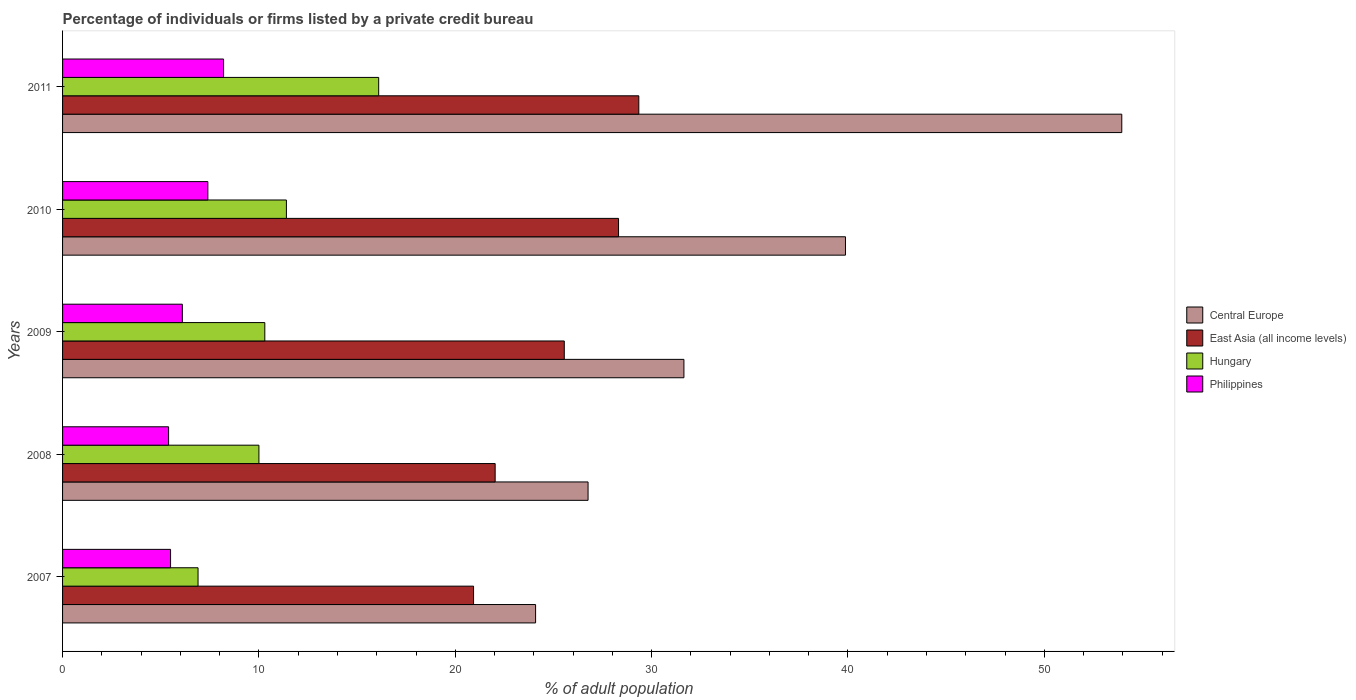How many bars are there on the 5th tick from the top?
Make the answer very short. 4. In how many cases, is the number of bars for a given year not equal to the number of legend labels?
Offer a very short reply. 0. Across all years, what is the maximum percentage of population listed by a private credit bureau in Central Europe?
Provide a short and direct response. 53.95. In which year was the percentage of population listed by a private credit bureau in East Asia (all income levels) maximum?
Your response must be concise. 2011. What is the total percentage of population listed by a private credit bureau in Central Europe in the graph?
Keep it short and to the point. 176.32. What is the difference between the percentage of population listed by a private credit bureau in Philippines in 2009 and that in 2011?
Keep it short and to the point. -2.1. What is the difference between the percentage of population listed by a private credit bureau in Philippines in 2011 and the percentage of population listed by a private credit bureau in Hungary in 2007?
Make the answer very short. 1.3. What is the average percentage of population listed by a private credit bureau in Hungary per year?
Your response must be concise. 10.94. In the year 2008, what is the difference between the percentage of population listed by a private credit bureau in East Asia (all income levels) and percentage of population listed by a private credit bureau in Hungary?
Offer a terse response. 12.03. What is the ratio of the percentage of population listed by a private credit bureau in Philippines in 2007 to that in 2008?
Ensure brevity in your answer.  1.02. Is the percentage of population listed by a private credit bureau in Central Europe in 2008 less than that in 2010?
Provide a succinct answer. Yes. What is the difference between the highest and the second highest percentage of population listed by a private credit bureau in Philippines?
Provide a short and direct response. 0.8. What is the difference between the highest and the lowest percentage of population listed by a private credit bureau in Philippines?
Your response must be concise. 2.8. Is the sum of the percentage of population listed by a private credit bureau in Hungary in 2009 and 2010 greater than the maximum percentage of population listed by a private credit bureau in Philippines across all years?
Offer a terse response. Yes. Is it the case that in every year, the sum of the percentage of population listed by a private credit bureau in Philippines and percentage of population listed by a private credit bureau in Central Europe is greater than the sum of percentage of population listed by a private credit bureau in East Asia (all income levels) and percentage of population listed by a private credit bureau in Hungary?
Provide a succinct answer. Yes. What does the 4th bar from the top in 2009 represents?
Ensure brevity in your answer.  Central Europe. What does the 2nd bar from the bottom in 2007 represents?
Keep it short and to the point. East Asia (all income levels). Is it the case that in every year, the sum of the percentage of population listed by a private credit bureau in Central Europe and percentage of population listed by a private credit bureau in East Asia (all income levels) is greater than the percentage of population listed by a private credit bureau in Philippines?
Give a very brief answer. Yes. What is the difference between two consecutive major ticks on the X-axis?
Offer a terse response. 10. Are the values on the major ticks of X-axis written in scientific E-notation?
Your answer should be compact. No. Does the graph contain any zero values?
Keep it short and to the point. No. Does the graph contain grids?
Your answer should be compact. No. Where does the legend appear in the graph?
Your answer should be compact. Center right. How many legend labels are there?
Make the answer very short. 4. How are the legend labels stacked?
Provide a short and direct response. Vertical. What is the title of the graph?
Offer a very short reply. Percentage of individuals or firms listed by a private credit bureau. What is the label or title of the X-axis?
Make the answer very short. % of adult population. What is the label or title of the Y-axis?
Your response must be concise. Years. What is the % of adult population in Central Europe in 2007?
Offer a very short reply. 24.09. What is the % of adult population of East Asia (all income levels) in 2007?
Your answer should be very brief. 20.93. What is the % of adult population of Philippines in 2007?
Offer a very short reply. 5.5. What is the % of adult population of Central Europe in 2008?
Your answer should be very brief. 26.76. What is the % of adult population in East Asia (all income levels) in 2008?
Your response must be concise. 22.03. What is the % of adult population of Central Europe in 2009?
Provide a short and direct response. 31.65. What is the % of adult population in East Asia (all income levels) in 2009?
Provide a succinct answer. 25.55. What is the % of adult population in Central Europe in 2010?
Your answer should be very brief. 39.87. What is the % of adult population of East Asia (all income levels) in 2010?
Your response must be concise. 28.32. What is the % of adult population in Hungary in 2010?
Give a very brief answer. 11.4. What is the % of adult population in Philippines in 2010?
Your answer should be compact. 7.4. What is the % of adult population in Central Europe in 2011?
Your answer should be compact. 53.95. What is the % of adult population in East Asia (all income levels) in 2011?
Provide a short and direct response. 29.35. What is the % of adult population in Hungary in 2011?
Make the answer very short. 16.1. Across all years, what is the maximum % of adult population in Central Europe?
Provide a succinct answer. 53.95. Across all years, what is the maximum % of adult population of East Asia (all income levels)?
Keep it short and to the point. 29.35. Across all years, what is the maximum % of adult population of Philippines?
Offer a terse response. 8.2. Across all years, what is the minimum % of adult population in Central Europe?
Your answer should be very brief. 24.09. Across all years, what is the minimum % of adult population in East Asia (all income levels)?
Offer a very short reply. 20.93. What is the total % of adult population of Central Europe in the graph?
Your answer should be very brief. 176.32. What is the total % of adult population in East Asia (all income levels) in the graph?
Keep it short and to the point. 126.18. What is the total % of adult population of Hungary in the graph?
Offer a terse response. 54.7. What is the total % of adult population of Philippines in the graph?
Provide a short and direct response. 32.6. What is the difference between the % of adult population of Central Europe in 2007 and that in 2008?
Your answer should be very brief. -2.67. What is the difference between the % of adult population of Hungary in 2007 and that in 2008?
Keep it short and to the point. -3.1. What is the difference between the % of adult population of Philippines in 2007 and that in 2008?
Give a very brief answer. 0.1. What is the difference between the % of adult population in Central Europe in 2007 and that in 2009?
Ensure brevity in your answer.  -7.55. What is the difference between the % of adult population in East Asia (all income levels) in 2007 and that in 2009?
Give a very brief answer. -4.62. What is the difference between the % of adult population of Hungary in 2007 and that in 2009?
Make the answer very short. -3.4. What is the difference between the % of adult population in Central Europe in 2007 and that in 2010?
Offer a very short reply. -15.78. What is the difference between the % of adult population of East Asia (all income levels) in 2007 and that in 2010?
Offer a terse response. -7.38. What is the difference between the % of adult population of Philippines in 2007 and that in 2010?
Your response must be concise. -1.9. What is the difference between the % of adult population in Central Europe in 2007 and that in 2011?
Give a very brief answer. -29.85. What is the difference between the % of adult population of East Asia (all income levels) in 2007 and that in 2011?
Your answer should be very brief. -8.42. What is the difference between the % of adult population of Hungary in 2007 and that in 2011?
Your answer should be very brief. -9.2. What is the difference between the % of adult population in Philippines in 2007 and that in 2011?
Your answer should be compact. -2.7. What is the difference between the % of adult population in Central Europe in 2008 and that in 2009?
Give a very brief answer. -4.88. What is the difference between the % of adult population of East Asia (all income levels) in 2008 and that in 2009?
Give a very brief answer. -3.52. What is the difference between the % of adult population in Philippines in 2008 and that in 2009?
Ensure brevity in your answer.  -0.7. What is the difference between the % of adult population of Central Europe in 2008 and that in 2010?
Provide a short and direct response. -13.11. What is the difference between the % of adult population of East Asia (all income levels) in 2008 and that in 2010?
Keep it short and to the point. -6.28. What is the difference between the % of adult population in Hungary in 2008 and that in 2010?
Offer a very short reply. -1.4. What is the difference between the % of adult population of Central Europe in 2008 and that in 2011?
Give a very brief answer. -27.18. What is the difference between the % of adult population in East Asia (all income levels) in 2008 and that in 2011?
Keep it short and to the point. -7.32. What is the difference between the % of adult population of Philippines in 2008 and that in 2011?
Give a very brief answer. -2.8. What is the difference between the % of adult population of Central Europe in 2009 and that in 2010?
Provide a short and direct response. -8.23. What is the difference between the % of adult population of East Asia (all income levels) in 2009 and that in 2010?
Your answer should be very brief. -2.76. What is the difference between the % of adult population of Philippines in 2009 and that in 2010?
Keep it short and to the point. -1.3. What is the difference between the % of adult population in Central Europe in 2009 and that in 2011?
Offer a terse response. -22.3. What is the difference between the % of adult population of East Asia (all income levels) in 2009 and that in 2011?
Give a very brief answer. -3.8. What is the difference between the % of adult population of Hungary in 2009 and that in 2011?
Give a very brief answer. -5.8. What is the difference between the % of adult population in Philippines in 2009 and that in 2011?
Your answer should be compact. -2.1. What is the difference between the % of adult population of Central Europe in 2010 and that in 2011?
Your response must be concise. -14.07. What is the difference between the % of adult population of East Asia (all income levels) in 2010 and that in 2011?
Your answer should be very brief. -1.03. What is the difference between the % of adult population in Philippines in 2010 and that in 2011?
Keep it short and to the point. -0.8. What is the difference between the % of adult population in Central Europe in 2007 and the % of adult population in East Asia (all income levels) in 2008?
Make the answer very short. 2.06. What is the difference between the % of adult population of Central Europe in 2007 and the % of adult population of Hungary in 2008?
Give a very brief answer. 14.09. What is the difference between the % of adult population in Central Europe in 2007 and the % of adult population in Philippines in 2008?
Keep it short and to the point. 18.69. What is the difference between the % of adult population in East Asia (all income levels) in 2007 and the % of adult population in Hungary in 2008?
Your answer should be very brief. 10.93. What is the difference between the % of adult population in East Asia (all income levels) in 2007 and the % of adult population in Philippines in 2008?
Keep it short and to the point. 15.53. What is the difference between the % of adult population of Hungary in 2007 and the % of adult population of Philippines in 2008?
Provide a short and direct response. 1.5. What is the difference between the % of adult population of Central Europe in 2007 and the % of adult population of East Asia (all income levels) in 2009?
Your answer should be very brief. -1.46. What is the difference between the % of adult population of Central Europe in 2007 and the % of adult population of Hungary in 2009?
Provide a short and direct response. 13.79. What is the difference between the % of adult population of Central Europe in 2007 and the % of adult population of Philippines in 2009?
Your response must be concise. 17.99. What is the difference between the % of adult population of East Asia (all income levels) in 2007 and the % of adult population of Hungary in 2009?
Provide a succinct answer. 10.63. What is the difference between the % of adult population in East Asia (all income levels) in 2007 and the % of adult population in Philippines in 2009?
Offer a terse response. 14.83. What is the difference between the % of adult population in Hungary in 2007 and the % of adult population in Philippines in 2009?
Your response must be concise. 0.8. What is the difference between the % of adult population of Central Europe in 2007 and the % of adult population of East Asia (all income levels) in 2010?
Keep it short and to the point. -4.23. What is the difference between the % of adult population of Central Europe in 2007 and the % of adult population of Hungary in 2010?
Offer a terse response. 12.69. What is the difference between the % of adult population in Central Europe in 2007 and the % of adult population in Philippines in 2010?
Keep it short and to the point. 16.69. What is the difference between the % of adult population in East Asia (all income levels) in 2007 and the % of adult population in Hungary in 2010?
Provide a succinct answer. 9.53. What is the difference between the % of adult population of East Asia (all income levels) in 2007 and the % of adult population of Philippines in 2010?
Make the answer very short. 13.53. What is the difference between the % of adult population of Central Europe in 2007 and the % of adult population of East Asia (all income levels) in 2011?
Your answer should be very brief. -5.26. What is the difference between the % of adult population of Central Europe in 2007 and the % of adult population of Hungary in 2011?
Provide a succinct answer. 7.99. What is the difference between the % of adult population of Central Europe in 2007 and the % of adult population of Philippines in 2011?
Your answer should be very brief. 15.89. What is the difference between the % of adult population of East Asia (all income levels) in 2007 and the % of adult population of Hungary in 2011?
Your answer should be very brief. 4.83. What is the difference between the % of adult population of East Asia (all income levels) in 2007 and the % of adult population of Philippines in 2011?
Provide a succinct answer. 12.73. What is the difference between the % of adult population in Hungary in 2007 and the % of adult population in Philippines in 2011?
Ensure brevity in your answer.  -1.3. What is the difference between the % of adult population of Central Europe in 2008 and the % of adult population of East Asia (all income levels) in 2009?
Give a very brief answer. 1.21. What is the difference between the % of adult population in Central Europe in 2008 and the % of adult population in Hungary in 2009?
Make the answer very short. 16.46. What is the difference between the % of adult population of Central Europe in 2008 and the % of adult population of Philippines in 2009?
Offer a very short reply. 20.66. What is the difference between the % of adult population of East Asia (all income levels) in 2008 and the % of adult population of Hungary in 2009?
Offer a terse response. 11.73. What is the difference between the % of adult population in East Asia (all income levels) in 2008 and the % of adult population in Philippines in 2009?
Your answer should be compact. 15.93. What is the difference between the % of adult population of Central Europe in 2008 and the % of adult population of East Asia (all income levels) in 2010?
Provide a short and direct response. -1.55. What is the difference between the % of adult population of Central Europe in 2008 and the % of adult population of Hungary in 2010?
Offer a terse response. 15.36. What is the difference between the % of adult population of Central Europe in 2008 and the % of adult population of Philippines in 2010?
Your answer should be compact. 19.36. What is the difference between the % of adult population in East Asia (all income levels) in 2008 and the % of adult population in Hungary in 2010?
Provide a succinct answer. 10.63. What is the difference between the % of adult population of East Asia (all income levels) in 2008 and the % of adult population of Philippines in 2010?
Ensure brevity in your answer.  14.63. What is the difference between the % of adult population in Central Europe in 2008 and the % of adult population in East Asia (all income levels) in 2011?
Your answer should be compact. -2.58. What is the difference between the % of adult population in Central Europe in 2008 and the % of adult population in Hungary in 2011?
Provide a succinct answer. 10.66. What is the difference between the % of adult population of Central Europe in 2008 and the % of adult population of Philippines in 2011?
Ensure brevity in your answer.  18.56. What is the difference between the % of adult population of East Asia (all income levels) in 2008 and the % of adult population of Hungary in 2011?
Offer a terse response. 5.93. What is the difference between the % of adult population in East Asia (all income levels) in 2008 and the % of adult population in Philippines in 2011?
Make the answer very short. 13.83. What is the difference between the % of adult population of Central Europe in 2009 and the % of adult population of East Asia (all income levels) in 2010?
Make the answer very short. 3.33. What is the difference between the % of adult population of Central Europe in 2009 and the % of adult population of Hungary in 2010?
Offer a very short reply. 20.25. What is the difference between the % of adult population in Central Europe in 2009 and the % of adult population in Philippines in 2010?
Offer a terse response. 24.25. What is the difference between the % of adult population in East Asia (all income levels) in 2009 and the % of adult population in Hungary in 2010?
Your response must be concise. 14.15. What is the difference between the % of adult population of East Asia (all income levels) in 2009 and the % of adult population of Philippines in 2010?
Offer a very short reply. 18.15. What is the difference between the % of adult population of Central Europe in 2009 and the % of adult population of East Asia (all income levels) in 2011?
Provide a succinct answer. 2.3. What is the difference between the % of adult population of Central Europe in 2009 and the % of adult population of Hungary in 2011?
Keep it short and to the point. 15.55. What is the difference between the % of adult population of Central Europe in 2009 and the % of adult population of Philippines in 2011?
Make the answer very short. 23.45. What is the difference between the % of adult population of East Asia (all income levels) in 2009 and the % of adult population of Hungary in 2011?
Give a very brief answer. 9.45. What is the difference between the % of adult population of East Asia (all income levels) in 2009 and the % of adult population of Philippines in 2011?
Offer a very short reply. 17.35. What is the difference between the % of adult population in Hungary in 2009 and the % of adult population in Philippines in 2011?
Your response must be concise. 2.1. What is the difference between the % of adult population of Central Europe in 2010 and the % of adult population of East Asia (all income levels) in 2011?
Your response must be concise. 10.52. What is the difference between the % of adult population of Central Europe in 2010 and the % of adult population of Hungary in 2011?
Your response must be concise. 23.77. What is the difference between the % of adult population of Central Europe in 2010 and the % of adult population of Philippines in 2011?
Make the answer very short. 31.67. What is the difference between the % of adult population in East Asia (all income levels) in 2010 and the % of adult population in Hungary in 2011?
Your answer should be compact. 12.22. What is the difference between the % of adult population in East Asia (all income levels) in 2010 and the % of adult population in Philippines in 2011?
Offer a terse response. 20.12. What is the average % of adult population of Central Europe per year?
Make the answer very short. 35.26. What is the average % of adult population of East Asia (all income levels) per year?
Provide a short and direct response. 25.24. What is the average % of adult population in Hungary per year?
Provide a succinct answer. 10.94. What is the average % of adult population of Philippines per year?
Ensure brevity in your answer.  6.52. In the year 2007, what is the difference between the % of adult population of Central Europe and % of adult population of East Asia (all income levels)?
Offer a very short reply. 3.16. In the year 2007, what is the difference between the % of adult population in Central Europe and % of adult population in Hungary?
Provide a short and direct response. 17.19. In the year 2007, what is the difference between the % of adult population of Central Europe and % of adult population of Philippines?
Provide a succinct answer. 18.59. In the year 2007, what is the difference between the % of adult population of East Asia (all income levels) and % of adult population of Hungary?
Offer a terse response. 14.03. In the year 2007, what is the difference between the % of adult population of East Asia (all income levels) and % of adult population of Philippines?
Keep it short and to the point. 15.43. In the year 2008, what is the difference between the % of adult population of Central Europe and % of adult population of East Asia (all income levels)?
Provide a short and direct response. 4.73. In the year 2008, what is the difference between the % of adult population in Central Europe and % of adult population in Hungary?
Ensure brevity in your answer.  16.76. In the year 2008, what is the difference between the % of adult population in Central Europe and % of adult population in Philippines?
Ensure brevity in your answer.  21.36. In the year 2008, what is the difference between the % of adult population of East Asia (all income levels) and % of adult population of Hungary?
Keep it short and to the point. 12.03. In the year 2008, what is the difference between the % of adult population of East Asia (all income levels) and % of adult population of Philippines?
Provide a short and direct response. 16.63. In the year 2008, what is the difference between the % of adult population of Hungary and % of adult population of Philippines?
Your answer should be compact. 4.6. In the year 2009, what is the difference between the % of adult population in Central Europe and % of adult population in East Asia (all income levels)?
Your answer should be very brief. 6.09. In the year 2009, what is the difference between the % of adult population of Central Europe and % of adult population of Hungary?
Offer a terse response. 21.35. In the year 2009, what is the difference between the % of adult population of Central Europe and % of adult population of Philippines?
Ensure brevity in your answer.  25.55. In the year 2009, what is the difference between the % of adult population of East Asia (all income levels) and % of adult population of Hungary?
Your answer should be very brief. 15.25. In the year 2009, what is the difference between the % of adult population in East Asia (all income levels) and % of adult population in Philippines?
Offer a very short reply. 19.45. In the year 2010, what is the difference between the % of adult population of Central Europe and % of adult population of East Asia (all income levels)?
Your response must be concise. 11.56. In the year 2010, what is the difference between the % of adult population of Central Europe and % of adult population of Hungary?
Give a very brief answer. 28.47. In the year 2010, what is the difference between the % of adult population in Central Europe and % of adult population in Philippines?
Offer a terse response. 32.47. In the year 2010, what is the difference between the % of adult population in East Asia (all income levels) and % of adult population in Hungary?
Your answer should be very brief. 16.92. In the year 2010, what is the difference between the % of adult population in East Asia (all income levels) and % of adult population in Philippines?
Offer a terse response. 20.92. In the year 2011, what is the difference between the % of adult population in Central Europe and % of adult population in East Asia (all income levels)?
Offer a very short reply. 24.6. In the year 2011, what is the difference between the % of adult population in Central Europe and % of adult population in Hungary?
Your answer should be compact. 37.85. In the year 2011, what is the difference between the % of adult population in Central Europe and % of adult population in Philippines?
Your answer should be compact. 45.75. In the year 2011, what is the difference between the % of adult population of East Asia (all income levels) and % of adult population of Hungary?
Your answer should be very brief. 13.25. In the year 2011, what is the difference between the % of adult population in East Asia (all income levels) and % of adult population in Philippines?
Give a very brief answer. 21.15. In the year 2011, what is the difference between the % of adult population in Hungary and % of adult population in Philippines?
Keep it short and to the point. 7.9. What is the ratio of the % of adult population of Central Europe in 2007 to that in 2008?
Your answer should be very brief. 0.9. What is the ratio of the % of adult population in East Asia (all income levels) in 2007 to that in 2008?
Keep it short and to the point. 0.95. What is the ratio of the % of adult population of Hungary in 2007 to that in 2008?
Provide a succinct answer. 0.69. What is the ratio of the % of adult population in Philippines in 2007 to that in 2008?
Ensure brevity in your answer.  1.02. What is the ratio of the % of adult population of Central Europe in 2007 to that in 2009?
Your response must be concise. 0.76. What is the ratio of the % of adult population in East Asia (all income levels) in 2007 to that in 2009?
Offer a very short reply. 0.82. What is the ratio of the % of adult population of Hungary in 2007 to that in 2009?
Offer a very short reply. 0.67. What is the ratio of the % of adult population of Philippines in 2007 to that in 2009?
Your answer should be very brief. 0.9. What is the ratio of the % of adult population in Central Europe in 2007 to that in 2010?
Your answer should be very brief. 0.6. What is the ratio of the % of adult population in East Asia (all income levels) in 2007 to that in 2010?
Your answer should be very brief. 0.74. What is the ratio of the % of adult population of Hungary in 2007 to that in 2010?
Provide a short and direct response. 0.61. What is the ratio of the % of adult population of Philippines in 2007 to that in 2010?
Ensure brevity in your answer.  0.74. What is the ratio of the % of adult population in Central Europe in 2007 to that in 2011?
Keep it short and to the point. 0.45. What is the ratio of the % of adult population in East Asia (all income levels) in 2007 to that in 2011?
Offer a very short reply. 0.71. What is the ratio of the % of adult population in Hungary in 2007 to that in 2011?
Your response must be concise. 0.43. What is the ratio of the % of adult population in Philippines in 2007 to that in 2011?
Provide a succinct answer. 0.67. What is the ratio of the % of adult population of Central Europe in 2008 to that in 2009?
Provide a short and direct response. 0.85. What is the ratio of the % of adult population in East Asia (all income levels) in 2008 to that in 2009?
Ensure brevity in your answer.  0.86. What is the ratio of the % of adult population of Hungary in 2008 to that in 2009?
Offer a terse response. 0.97. What is the ratio of the % of adult population in Philippines in 2008 to that in 2009?
Your answer should be very brief. 0.89. What is the ratio of the % of adult population of Central Europe in 2008 to that in 2010?
Ensure brevity in your answer.  0.67. What is the ratio of the % of adult population of East Asia (all income levels) in 2008 to that in 2010?
Your answer should be compact. 0.78. What is the ratio of the % of adult population of Hungary in 2008 to that in 2010?
Your answer should be compact. 0.88. What is the ratio of the % of adult population in Philippines in 2008 to that in 2010?
Provide a short and direct response. 0.73. What is the ratio of the % of adult population of Central Europe in 2008 to that in 2011?
Offer a terse response. 0.5. What is the ratio of the % of adult population of East Asia (all income levels) in 2008 to that in 2011?
Keep it short and to the point. 0.75. What is the ratio of the % of adult population in Hungary in 2008 to that in 2011?
Keep it short and to the point. 0.62. What is the ratio of the % of adult population in Philippines in 2008 to that in 2011?
Give a very brief answer. 0.66. What is the ratio of the % of adult population of Central Europe in 2009 to that in 2010?
Give a very brief answer. 0.79. What is the ratio of the % of adult population in East Asia (all income levels) in 2009 to that in 2010?
Provide a short and direct response. 0.9. What is the ratio of the % of adult population of Hungary in 2009 to that in 2010?
Your answer should be very brief. 0.9. What is the ratio of the % of adult population of Philippines in 2009 to that in 2010?
Provide a succinct answer. 0.82. What is the ratio of the % of adult population in Central Europe in 2009 to that in 2011?
Your response must be concise. 0.59. What is the ratio of the % of adult population in East Asia (all income levels) in 2009 to that in 2011?
Your answer should be very brief. 0.87. What is the ratio of the % of adult population in Hungary in 2009 to that in 2011?
Your answer should be compact. 0.64. What is the ratio of the % of adult population in Philippines in 2009 to that in 2011?
Make the answer very short. 0.74. What is the ratio of the % of adult population of Central Europe in 2010 to that in 2011?
Make the answer very short. 0.74. What is the ratio of the % of adult population in East Asia (all income levels) in 2010 to that in 2011?
Offer a terse response. 0.96. What is the ratio of the % of adult population in Hungary in 2010 to that in 2011?
Provide a short and direct response. 0.71. What is the ratio of the % of adult population of Philippines in 2010 to that in 2011?
Ensure brevity in your answer.  0.9. What is the difference between the highest and the second highest % of adult population in Central Europe?
Provide a succinct answer. 14.07. What is the difference between the highest and the second highest % of adult population in East Asia (all income levels)?
Provide a succinct answer. 1.03. What is the difference between the highest and the second highest % of adult population of Hungary?
Your answer should be very brief. 4.7. What is the difference between the highest and the lowest % of adult population in Central Europe?
Make the answer very short. 29.85. What is the difference between the highest and the lowest % of adult population of East Asia (all income levels)?
Offer a very short reply. 8.42. 